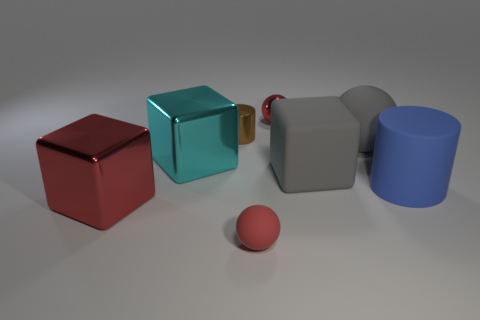What color is the cylinder that is the same size as the red shiny block?
Make the answer very short. Blue. How big is the metallic cube left of the big shiny object that is behind the big blue matte thing?
Ensure brevity in your answer.  Large. There is a shiny ball; is it the same color as the tiny object in front of the rubber block?
Make the answer very short. Yes. Are there fewer big red shiny objects that are on the left side of the large red cube than large brown matte blocks?
Provide a short and direct response. No. What number of other things are there of the same size as the cyan metal cube?
Offer a very short reply. 4. Is the shape of the big gray thing to the right of the large rubber cube the same as  the big blue thing?
Your answer should be very brief. No. Are there more shiny blocks behind the tiny brown metallic cylinder than small red shiny things?
Keep it short and to the point. No. What is the big thing that is behind the large red block and in front of the gray block made of?
Ensure brevity in your answer.  Rubber. How many things are both in front of the cyan shiny cube and on the right side of the small matte ball?
Your response must be concise. 2. What is the material of the large cyan object?
Give a very brief answer. Metal. 